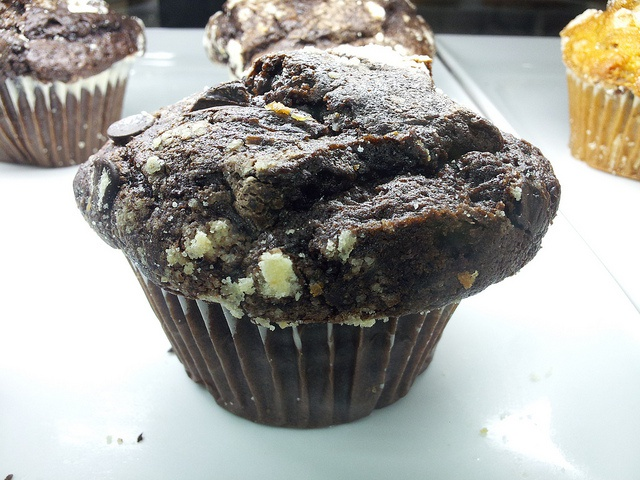Describe the objects in this image and their specific colors. I can see dining table in gray, white, darkgray, and lightgray tones, cake in gray, black, lightgray, and darkgray tones, cake in gray, darkgray, and lightgray tones, cake in gray, ivory, darkgray, and tan tones, and cake in gray, tan, gold, khaki, and orange tones in this image. 